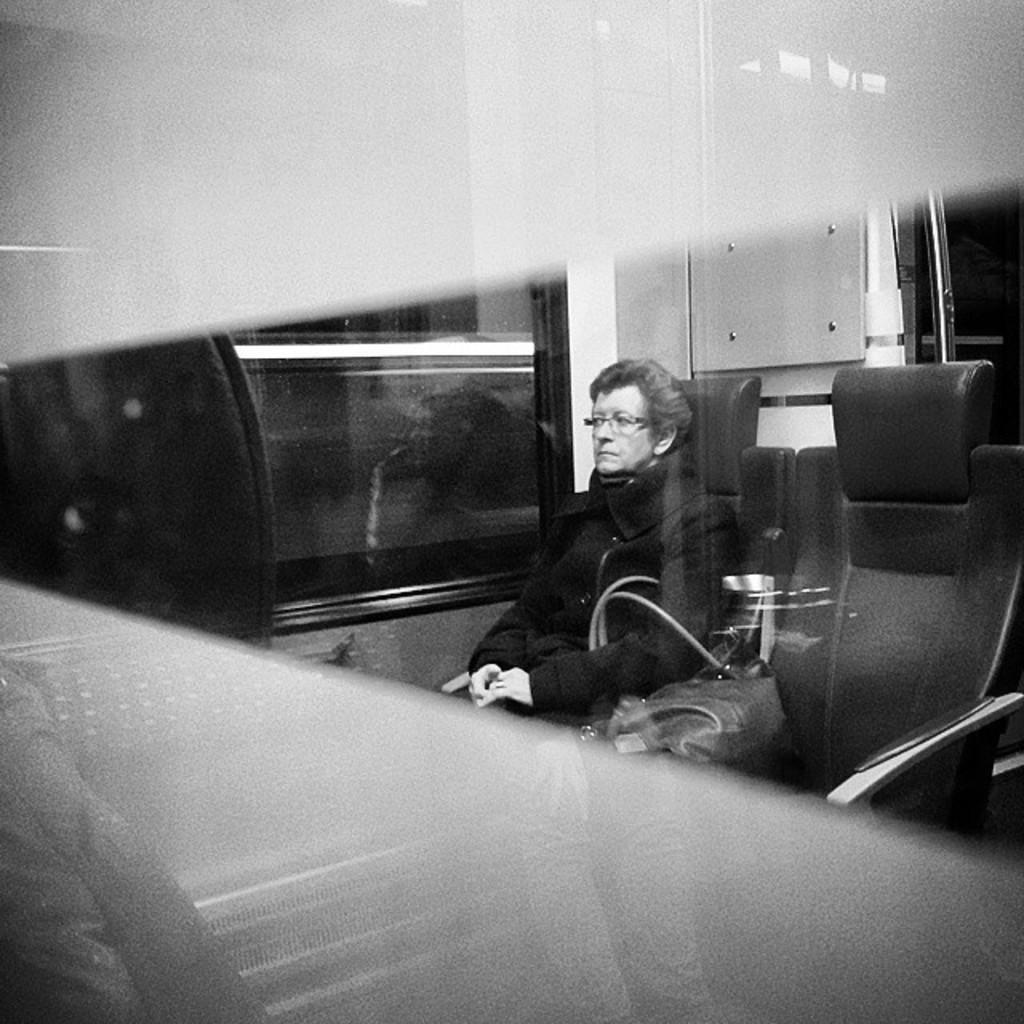Describe this image in one or two sentences. This is a black and white image. In this image there is a lady wearing specs is holding a bag is sitting on a chair. Near to her there is a glass window. Also there is a box on the wall. And there is a chair. 